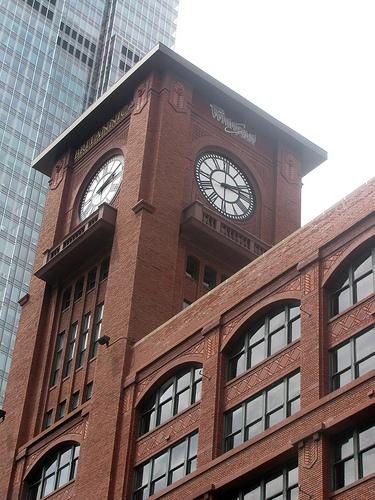Question: what is it?
Choices:
A. Houses.
B. Buildings.
C. Shops.
D. Warehouses.
Answer with the letter. Answer: B Question: what is on the building?
Choices:
A. Lights.
B. A sign.
C. A decorative design.
D. Clock.
Answer with the letter. Answer: D Question: where is the clock?
Choices:
A. In the tower.
B. On the building.
C. On the side of a buidling.
D. Above the sign.
Answer with the letter. Answer: B 